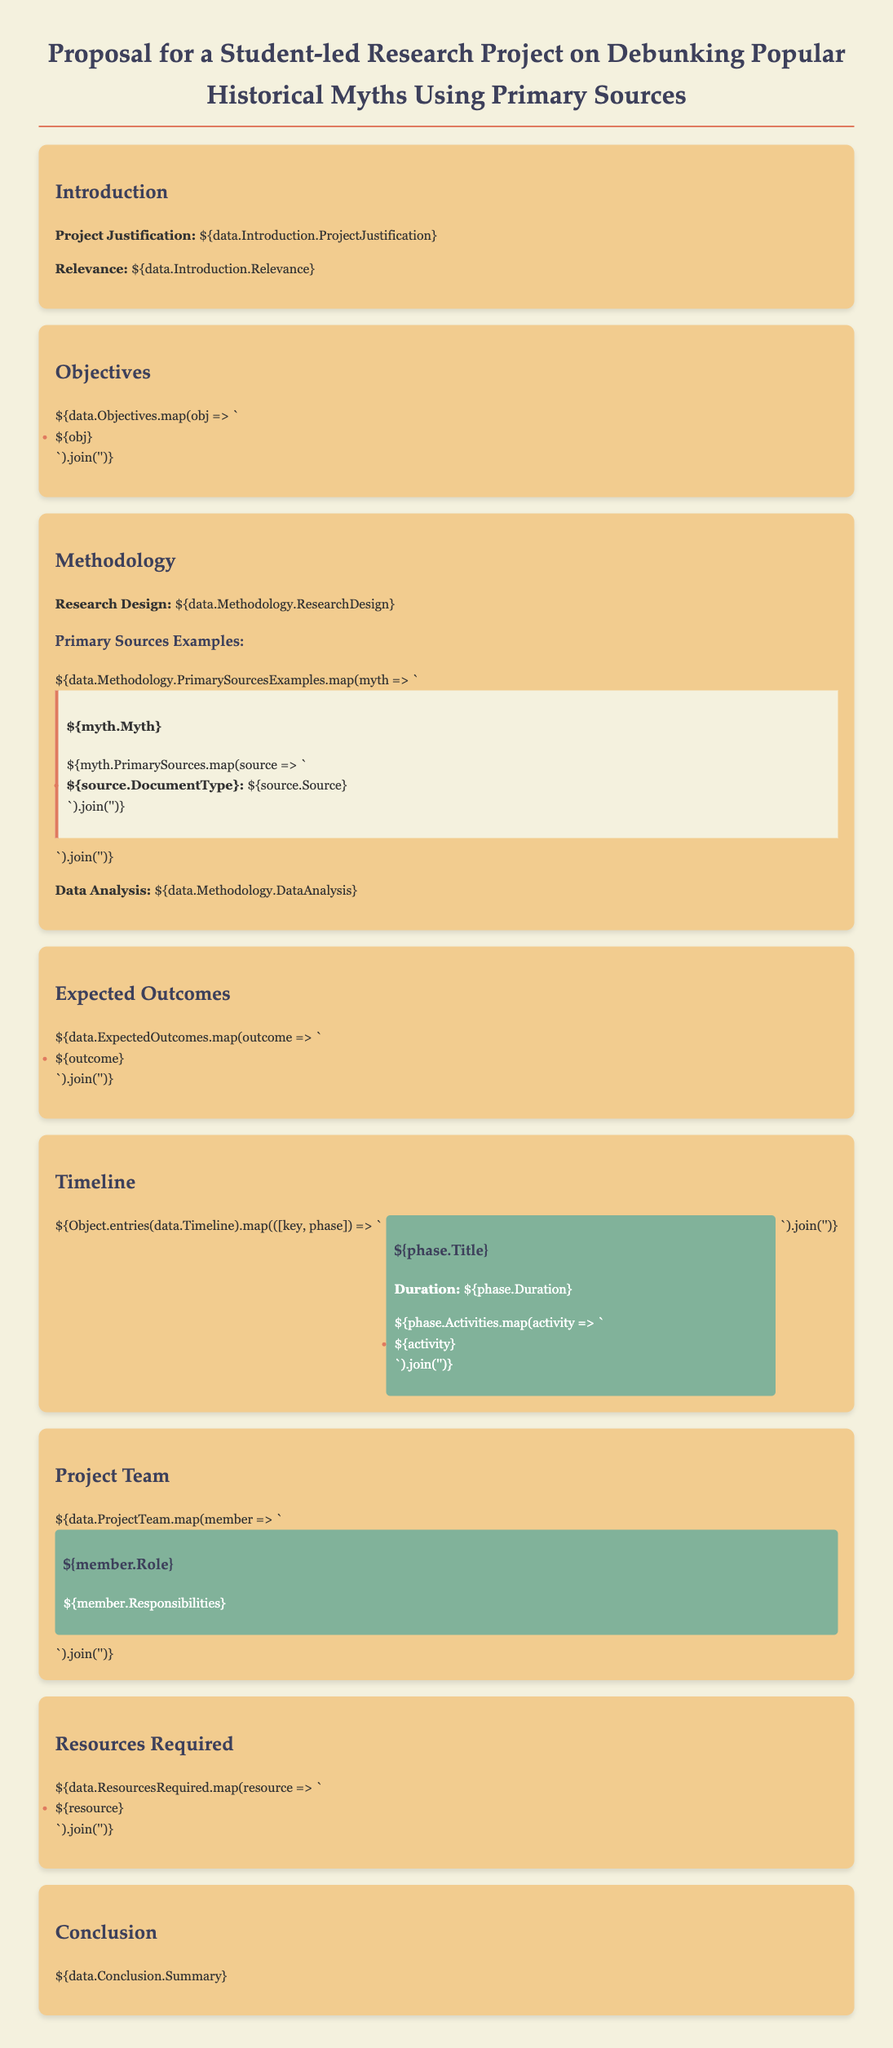What is the project title? The project title is stated clearly at the beginning of the document.
Answer: Proposal for a Student-led Research Project on Debunking Popular Historical Myths Using Primary Sources What is the duration of the first phase in the timeline? Each phase's duration is mentioned under the timeline section.
Answer: Duration: 4 weeks What type of sources will be used in the research? The methodology section mentions the type of sources and gives examples.
Answer: Primary Sources Who is responsible for research design? The project team includes roles and their responsibilities outlined in the document.
Answer: Research lead What is one expected outcome of the project? Expected outcomes are listed in a dedicated section of the document.
Answer: Increased understanding of historical accuracy How many myths are provided as examples in the methodology section? The number of myths can be counted from the listed examples in the methodology section.
Answer: 3 myths What is the background color of the project team section? The styling of various sections indicates their background colors.
Answer: Green What is one resource required for the project? Resources required are listed clearly in their dedicated section of the proposal.
Answer: Access to archives What does the conclusion summarize? The conclusion section provides an overall summary of the project's aims and findings.
Answer: Project Summary 